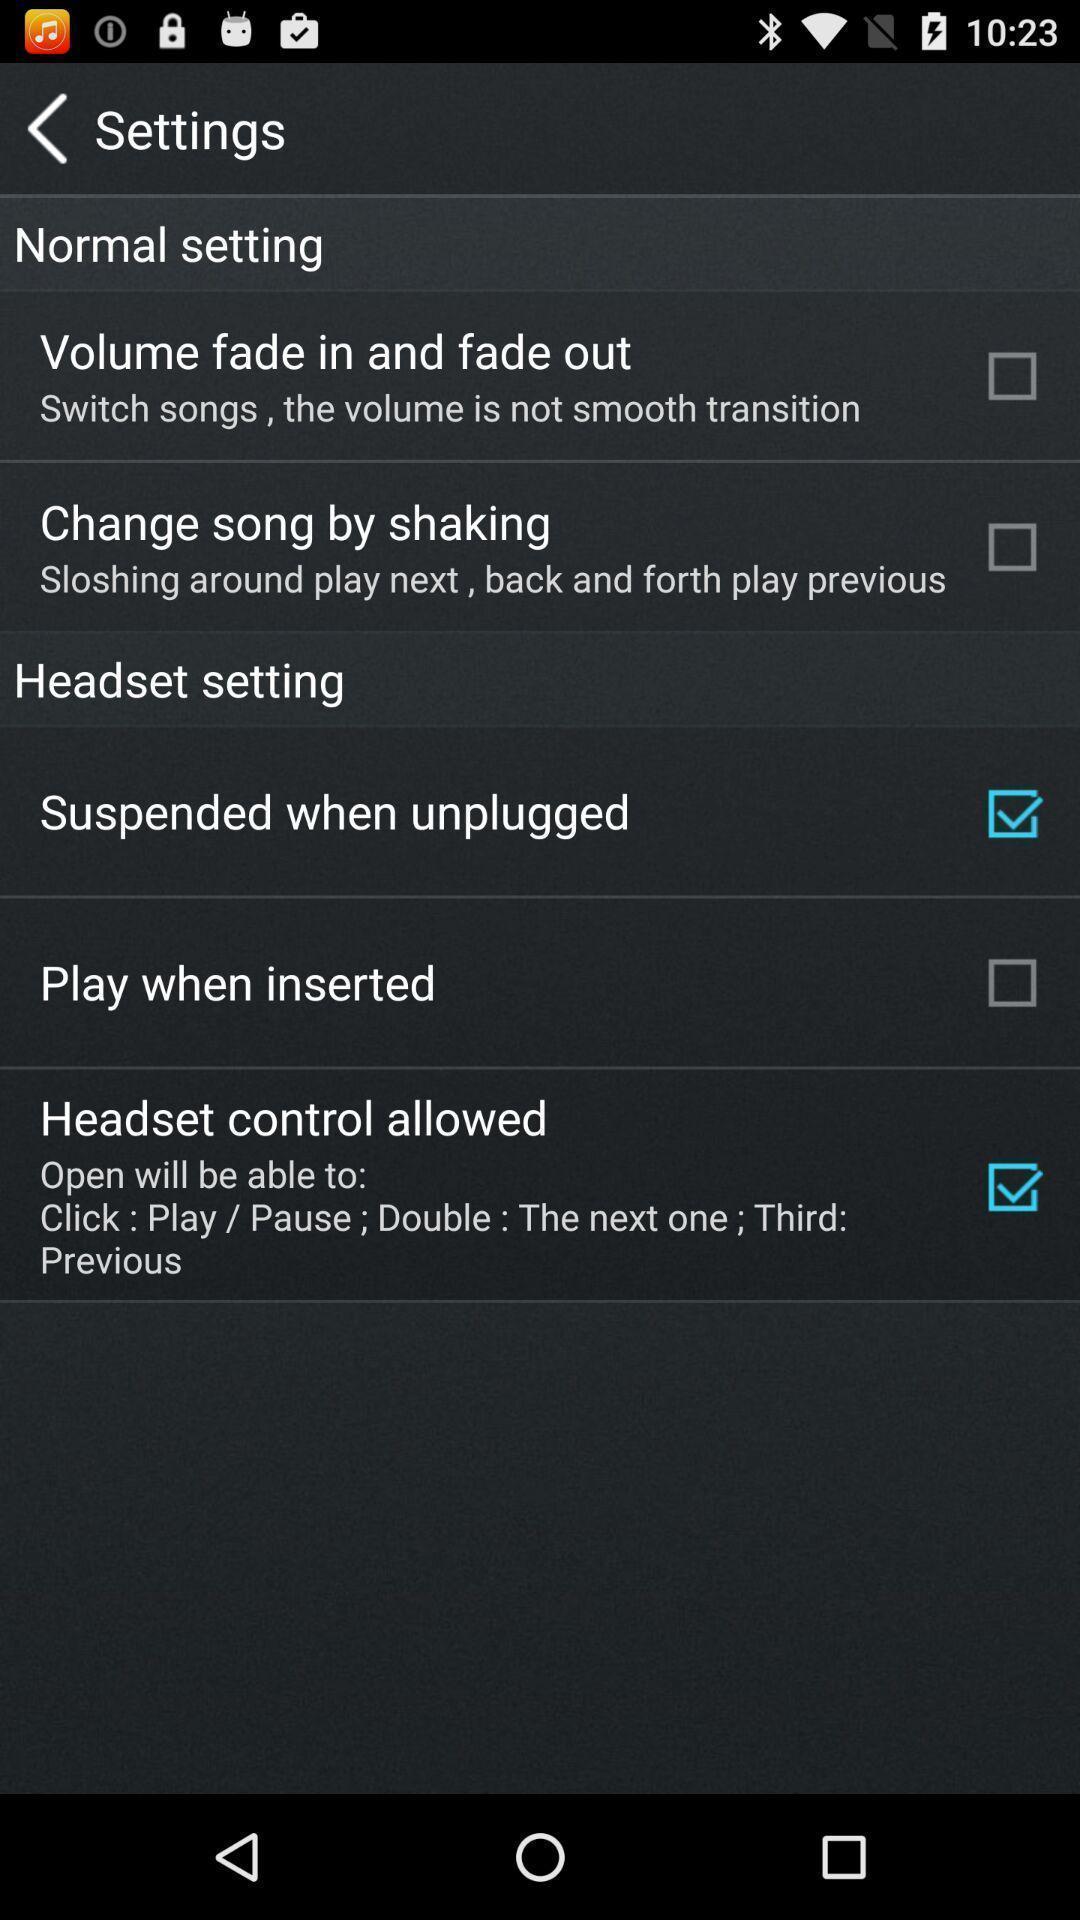Provide a detailed account of this screenshot. Settings tab with different options. 